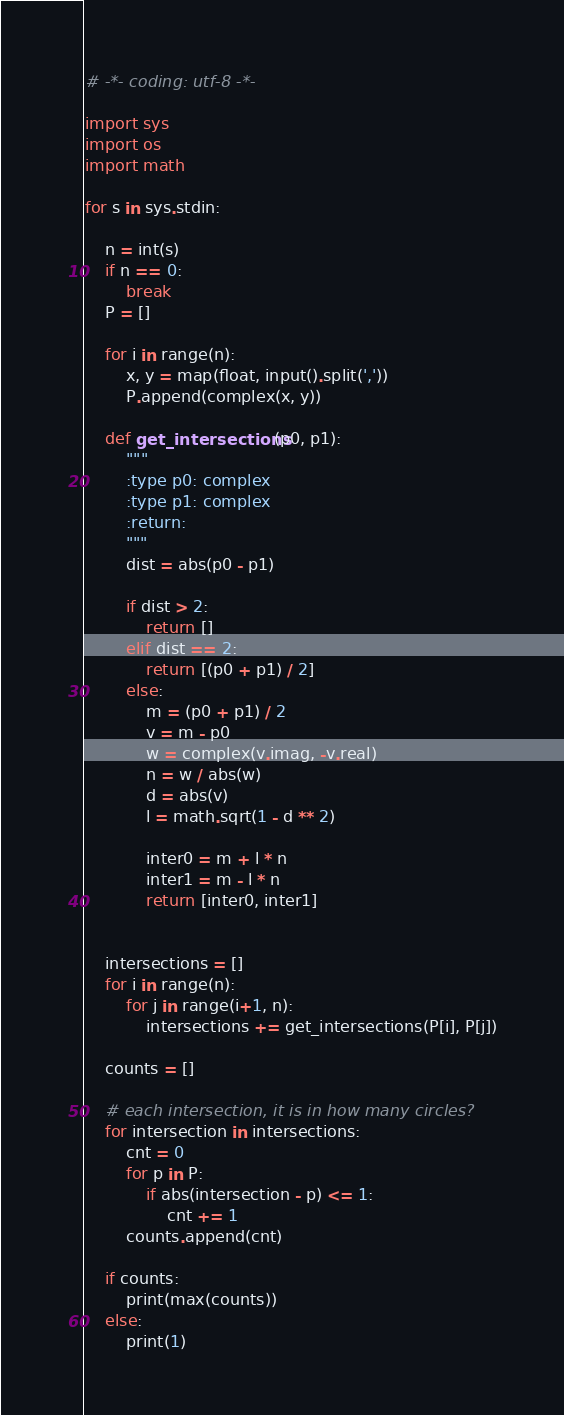Convert code to text. <code><loc_0><loc_0><loc_500><loc_500><_Python_># -*- coding: utf-8 -*-

import sys
import os
import math

for s in sys.stdin:

    n = int(s)
    if n == 0:
        break
    P = []

    for i in range(n):
        x, y = map(float, input().split(','))
        P.append(complex(x, y))

    def get_intersections(p0, p1):
        """
        :type p0: complex
        :type p1: complex
        :return:
        """
        dist = abs(p0 - p1)

        if dist > 2:
            return []
        elif dist == 2:
            return [(p0 + p1) / 2]
        else:
            m = (p0 + p1) / 2
            v = m - p0
            w = complex(v.imag, -v.real)
            n = w / abs(w)
            d = abs(v)
            l = math.sqrt(1 - d ** 2)

            inter0 = m + l * n
            inter1 = m - l * n
            return [inter0, inter1]


    intersections = []
    for i in range(n):
        for j in range(i+1, n):
            intersections += get_intersections(P[i], P[j])

    counts = []

    # each intersection, it is in how many circles?
    for intersection in intersections:
        cnt = 0
        for p in P:
            if abs(intersection - p) <= 1:
                cnt += 1
        counts.append(cnt)

    if counts:
        print(max(counts))
    else:
        print(1)</code> 